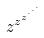<formula> <loc_0><loc_0><loc_500><loc_500>z ^ { z ^ { z ^ { \cdot ^ { \cdot ^ { \cdot } } } } }</formula> 